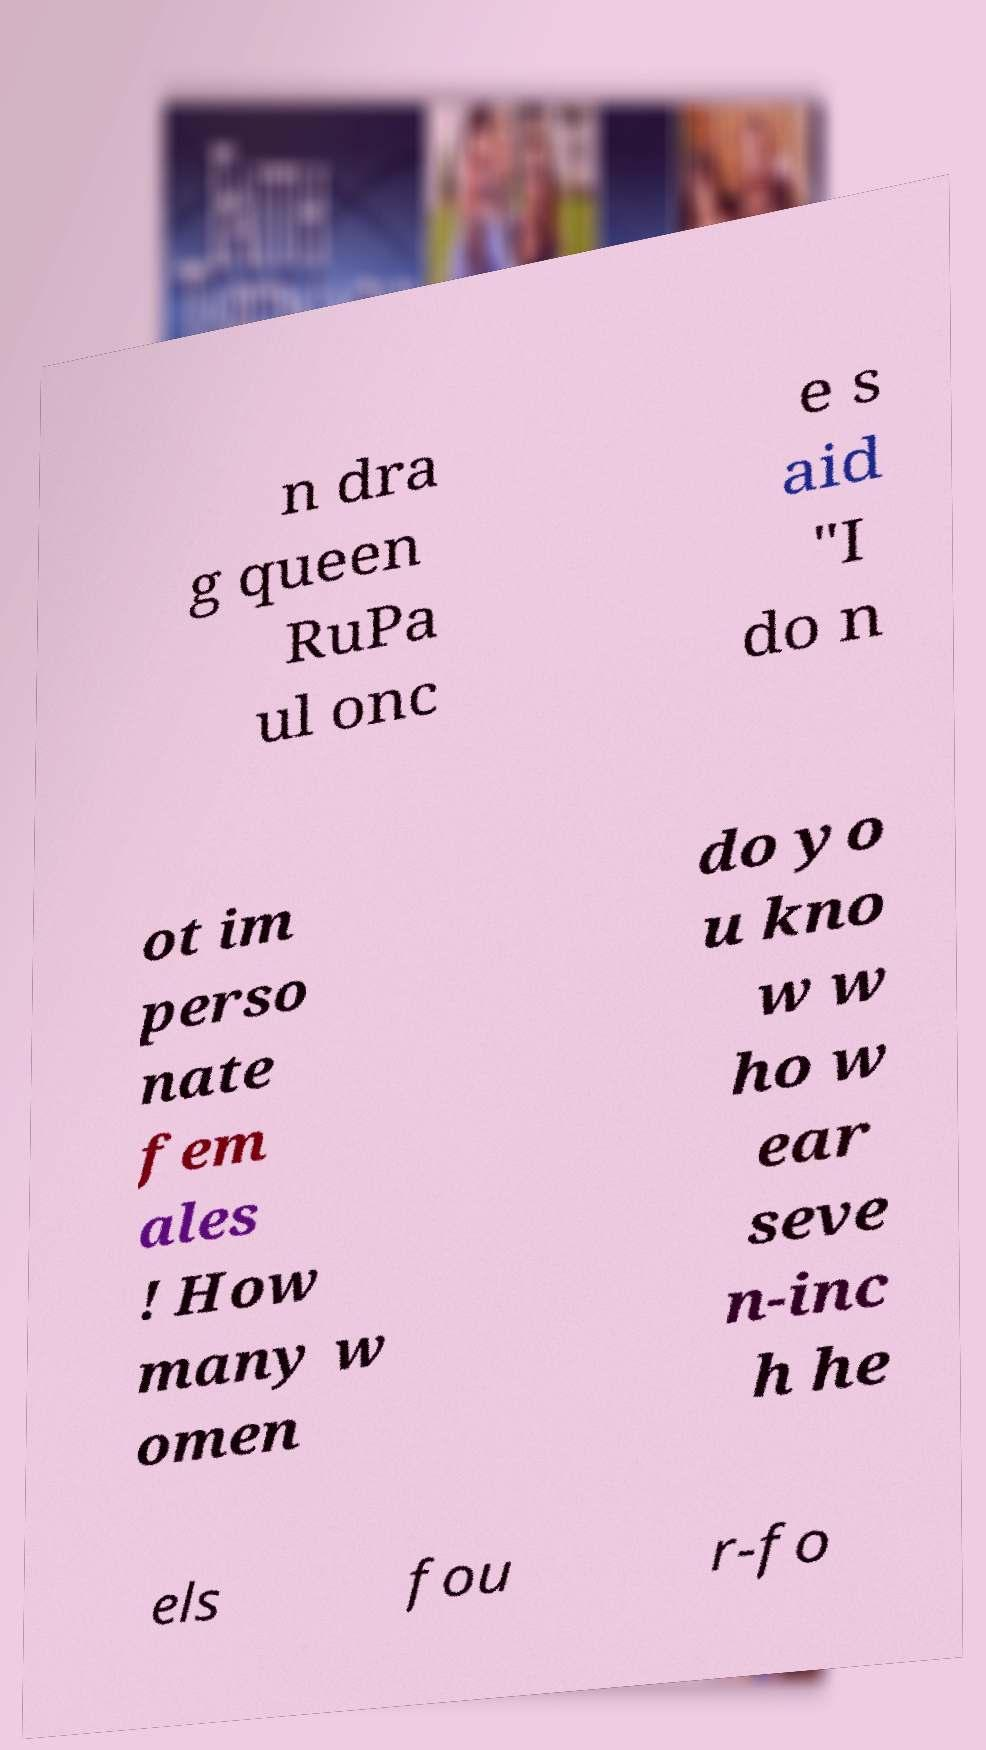I need the written content from this picture converted into text. Can you do that? n dra g queen RuPa ul onc e s aid "I do n ot im perso nate fem ales ! How many w omen do yo u kno w w ho w ear seve n-inc h he els fou r-fo 